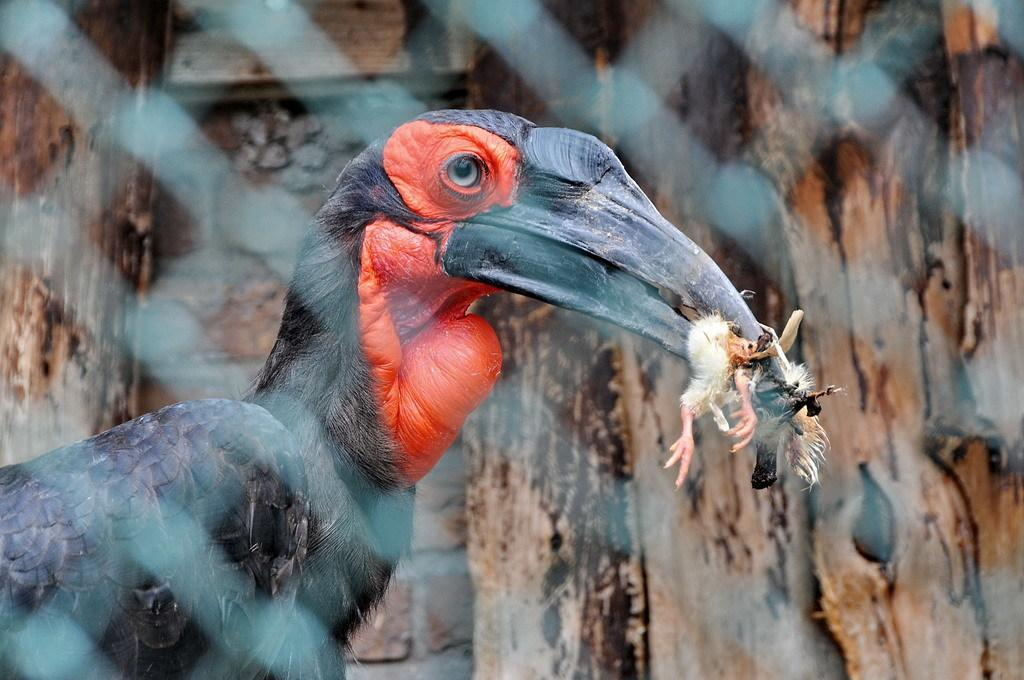What is the main subject in the center of the image? There is a bird in the center of the image. Can you describe the colors of the bird? The bird has red and black colors. What is the bird doing in the image? The bird is holding a small bird. What can be seen in the background of the image? There is a wall in the background of the image. What type of mint is growing on the wall in the image? There is no mint plant visible in the image; the background only shows a wall. 